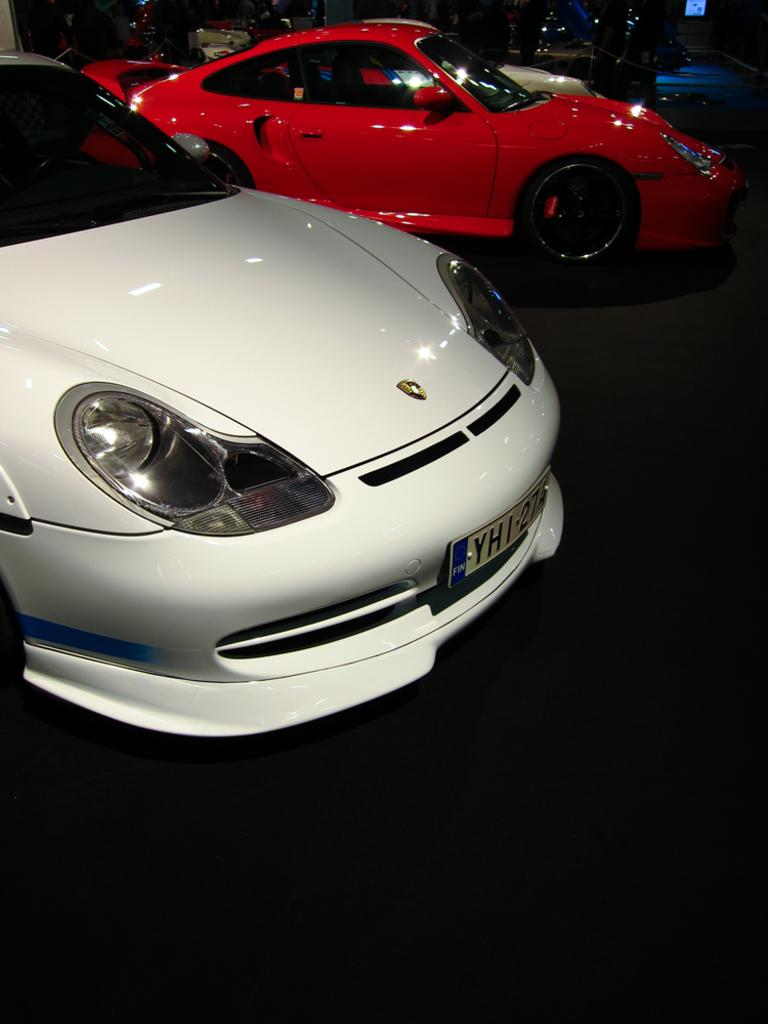What colors are the cars in the image? The cars in the image are white and red. Where are the cars located in the image? The cars are on the floor. What can be observed about the background of the image? The background of the image is dark. Can you see any waves in the image? There are no waves present in the image; it features white and red cars on the floor with a dark background. 